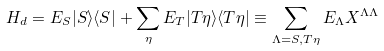Convert formula to latex. <formula><loc_0><loc_0><loc_500><loc_500>H _ { d } = E _ { S } | S \rangle \langle S | + \sum _ { \eta } E _ { T } | T \eta \rangle \langle T \eta | \equiv \sum _ { \Lambda = S , T \eta } E _ { \Lambda } X ^ { \Lambda \Lambda }</formula> 